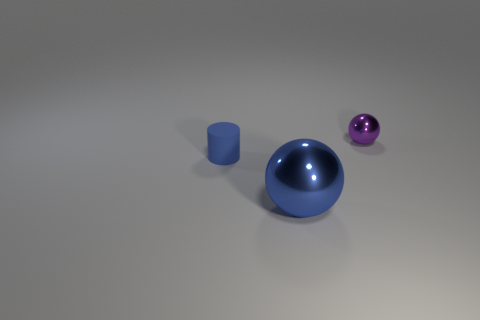Add 1 small blue matte objects. How many objects exist? 4 Subtract all spheres. How many objects are left? 1 Subtract 0 green spheres. How many objects are left? 3 Subtract all small blue objects. Subtract all rubber things. How many objects are left? 1 Add 2 large objects. How many large objects are left? 3 Add 3 small green shiny cylinders. How many small green shiny cylinders exist? 3 